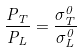Convert formula to latex. <formula><loc_0><loc_0><loc_500><loc_500>\frac { P _ { T } } { P _ { L } } = \frac { \sigma _ { T } ^ { 0 } } { \sigma _ { L } ^ { 0 } }</formula> 